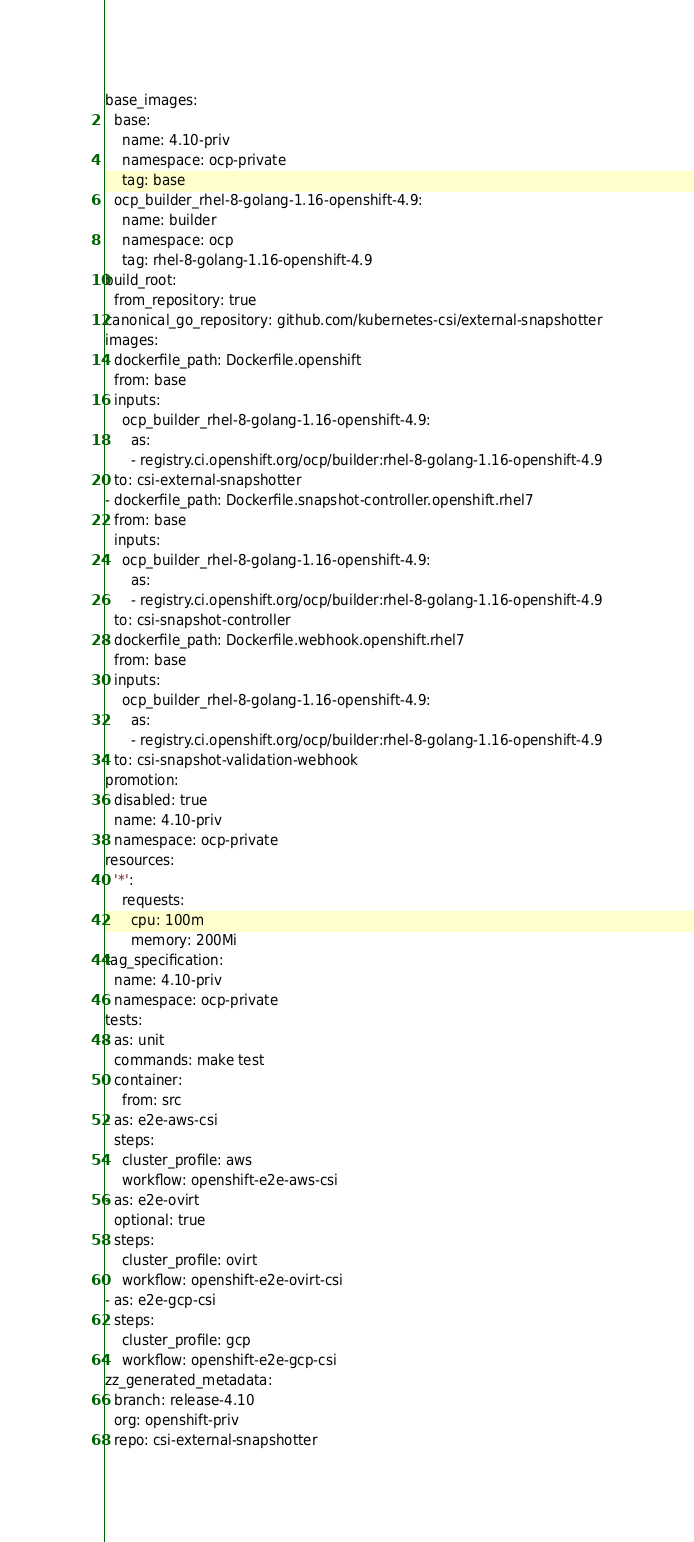Convert code to text. <code><loc_0><loc_0><loc_500><loc_500><_YAML_>base_images:
  base:
    name: 4.10-priv
    namespace: ocp-private
    tag: base
  ocp_builder_rhel-8-golang-1.16-openshift-4.9:
    name: builder
    namespace: ocp
    tag: rhel-8-golang-1.16-openshift-4.9
build_root:
  from_repository: true
canonical_go_repository: github.com/kubernetes-csi/external-snapshotter
images:
- dockerfile_path: Dockerfile.openshift
  from: base
  inputs:
    ocp_builder_rhel-8-golang-1.16-openshift-4.9:
      as:
      - registry.ci.openshift.org/ocp/builder:rhel-8-golang-1.16-openshift-4.9
  to: csi-external-snapshotter
- dockerfile_path: Dockerfile.snapshot-controller.openshift.rhel7
  from: base
  inputs:
    ocp_builder_rhel-8-golang-1.16-openshift-4.9:
      as:
      - registry.ci.openshift.org/ocp/builder:rhel-8-golang-1.16-openshift-4.9
  to: csi-snapshot-controller
- dockerfile_path: Dockerfile.webhook.openshift.rhel7
  from: base
  inputs:
    ocp_builder_rhel-8-golang-1.16-openshift-4.9:
      as:
      - registry.ci.openshift.org/ocp/builder:rhel-8-golang-1.16-openshift-4.9
  to: csi-snapshot-validation-webhook
promotion:
  disabled: true
  name: 4.10-priv
  namespace: ocp-private
resources:
  '*':
    requests:
      cpu: 100m
      memory: 200Mi
tag_specification:
  name: 4.10-priv
  namespace: ocp-private
tests:
- as: unit
  commands: make test
  container:
    from: src
- as: e2e-aws-csi
  steps:
    cluster_profile: aws
    workflow: openshift-e2e-aws-csi
- as: e2e-ovirt
  optional: true
  steps:
    cluster_profile: ovirt
    workflow: openshift-e2e-ovirt-csi
- as: e2e-gcp-csi
  steps:
    cluster_profile: gcp
    workflow: openshift-e2e-gcp-csi
zz_generated_metadata:
  branch: release-4.10
  org: openshift-priv
  repo: csi-external-snapshotter
</code> 